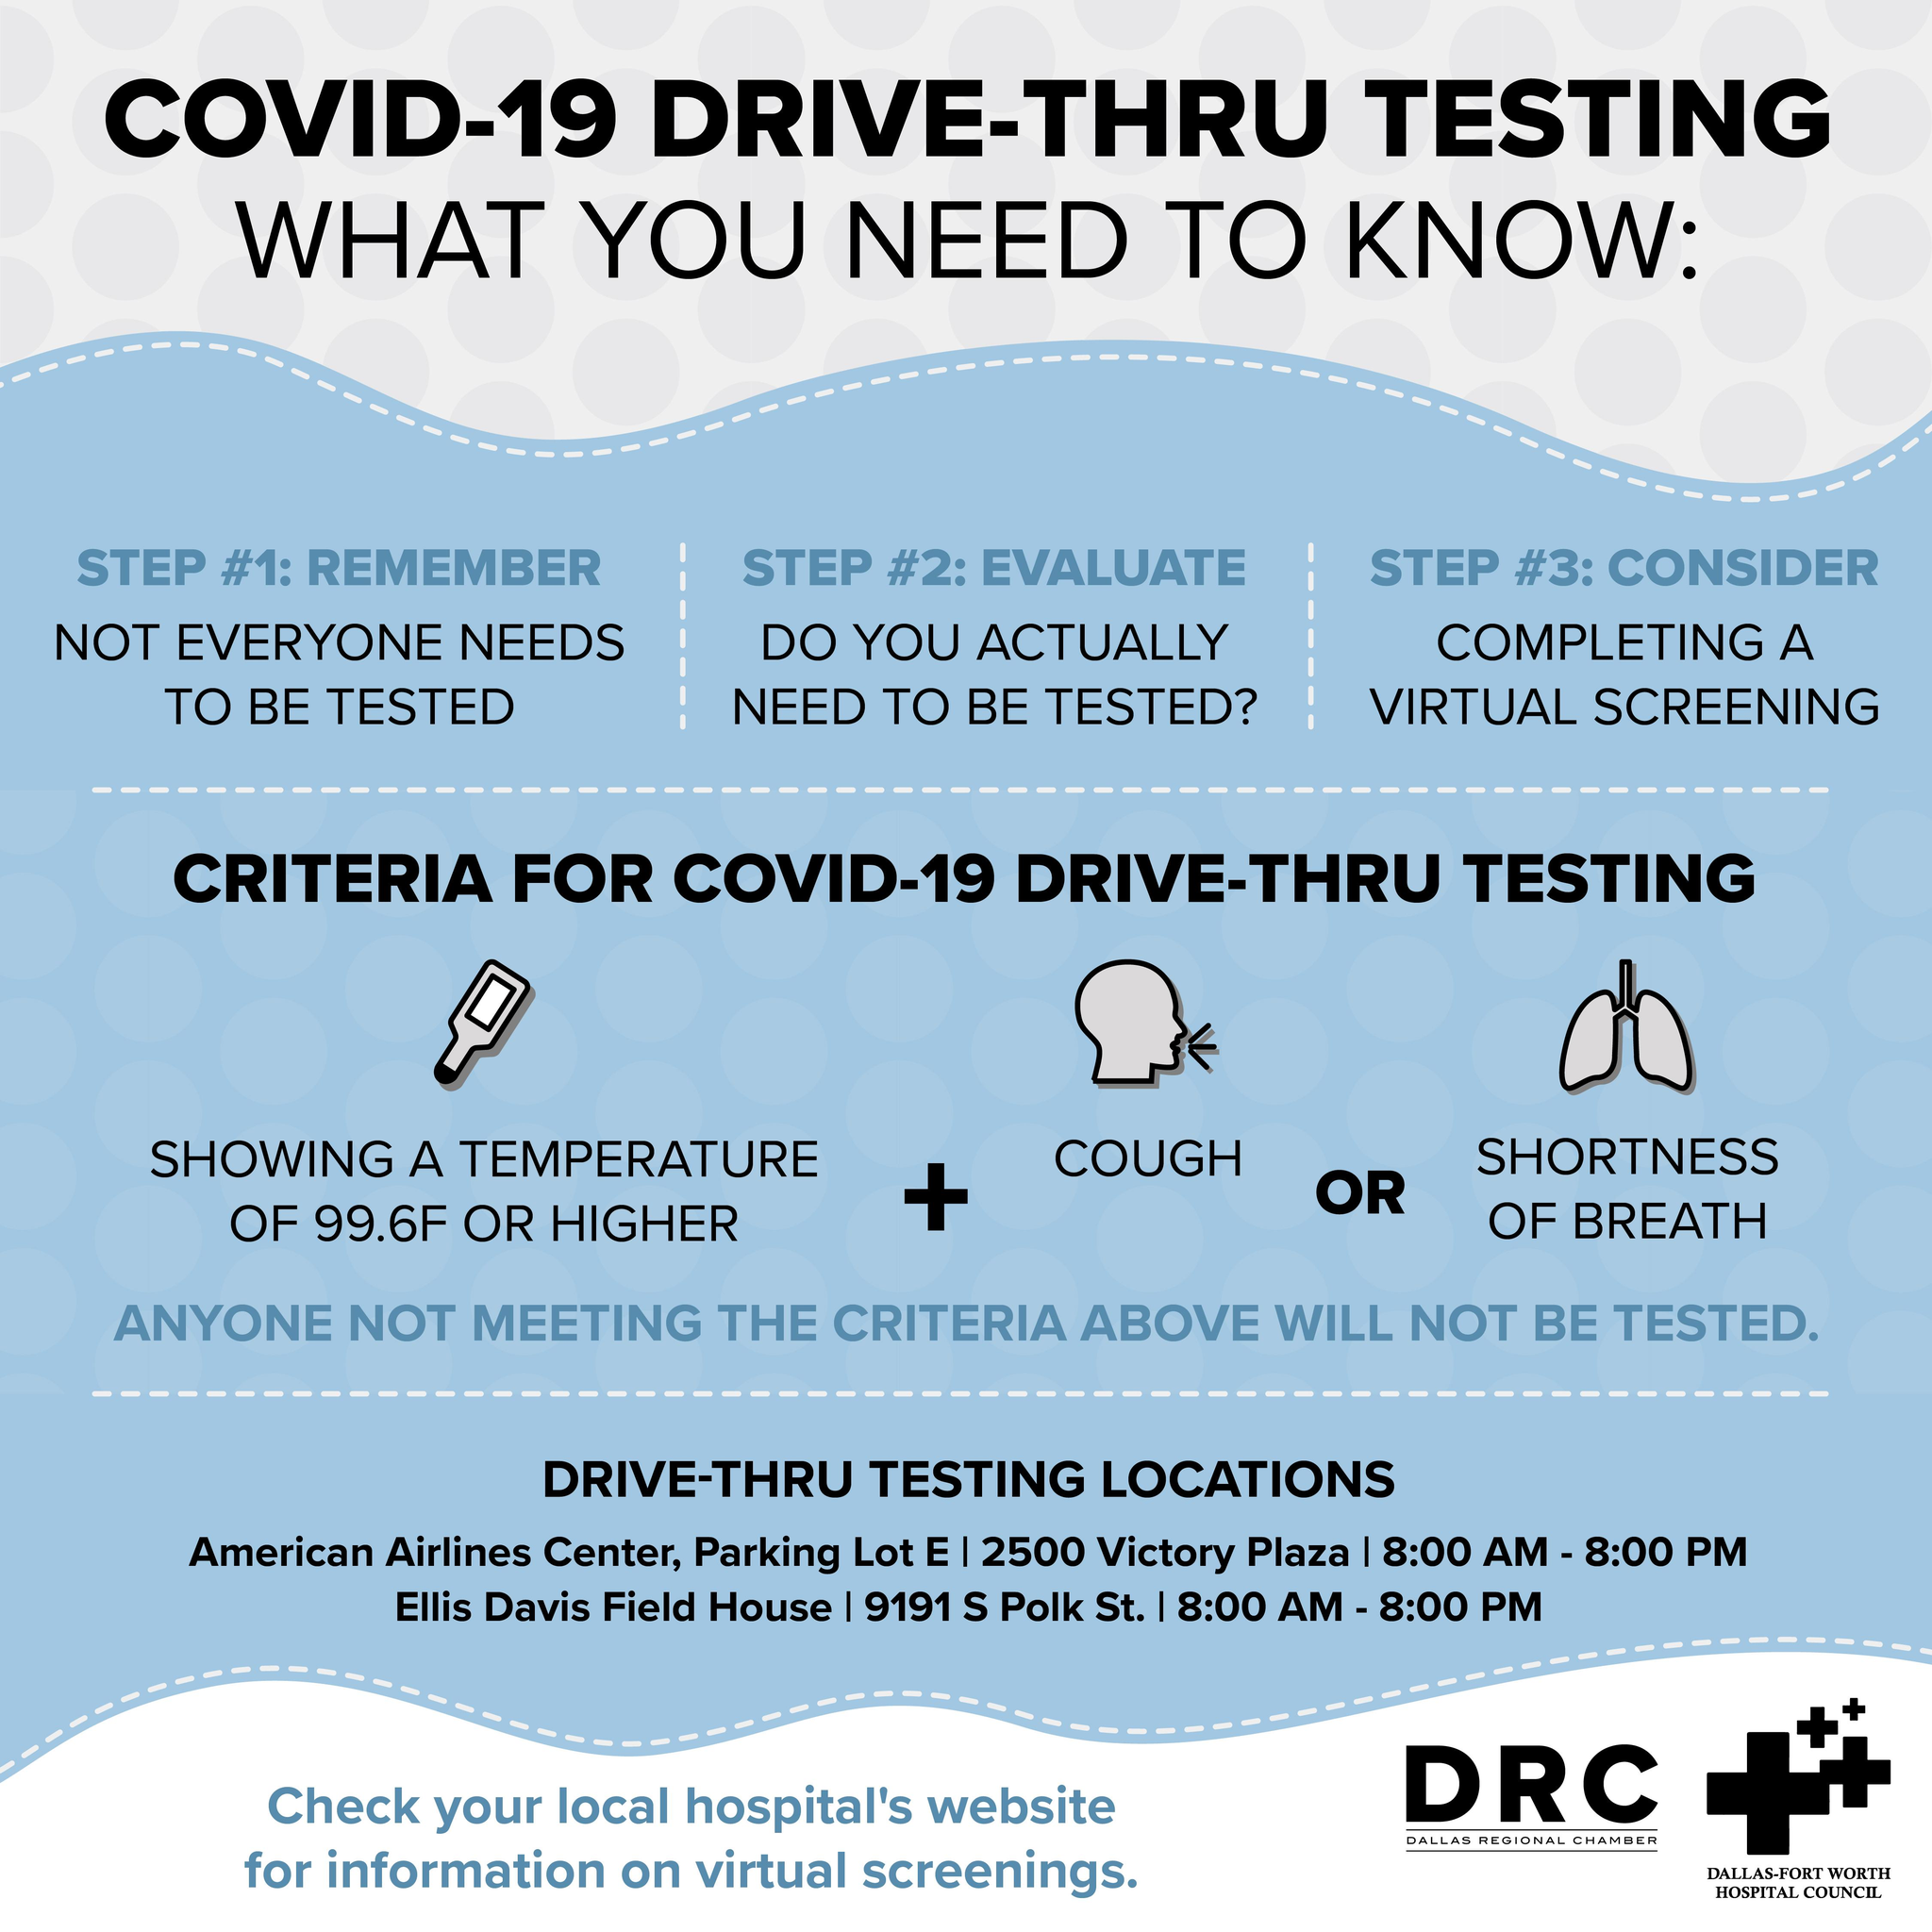List a handful of essential elements in this visual. The first criteria for Covid-19 drive-through testing requires a temperature of 99.6 degrees Fahrenheit or higher. The third step of Covid-19 drive-thru testing involves completing a virtual screening. Before undergoing Covid-19 drive-thru testing, it is essential to complete three steps: evaluate, consider, and follow the instructions provided by the testing staff. The second step of Covid-19 drive-thru testing involves a need-based approach, where individuals are required or recommended to be tested based on their potential exposure to the virus. Two criteria are given in the OR condition: cough and shortness of breath. 